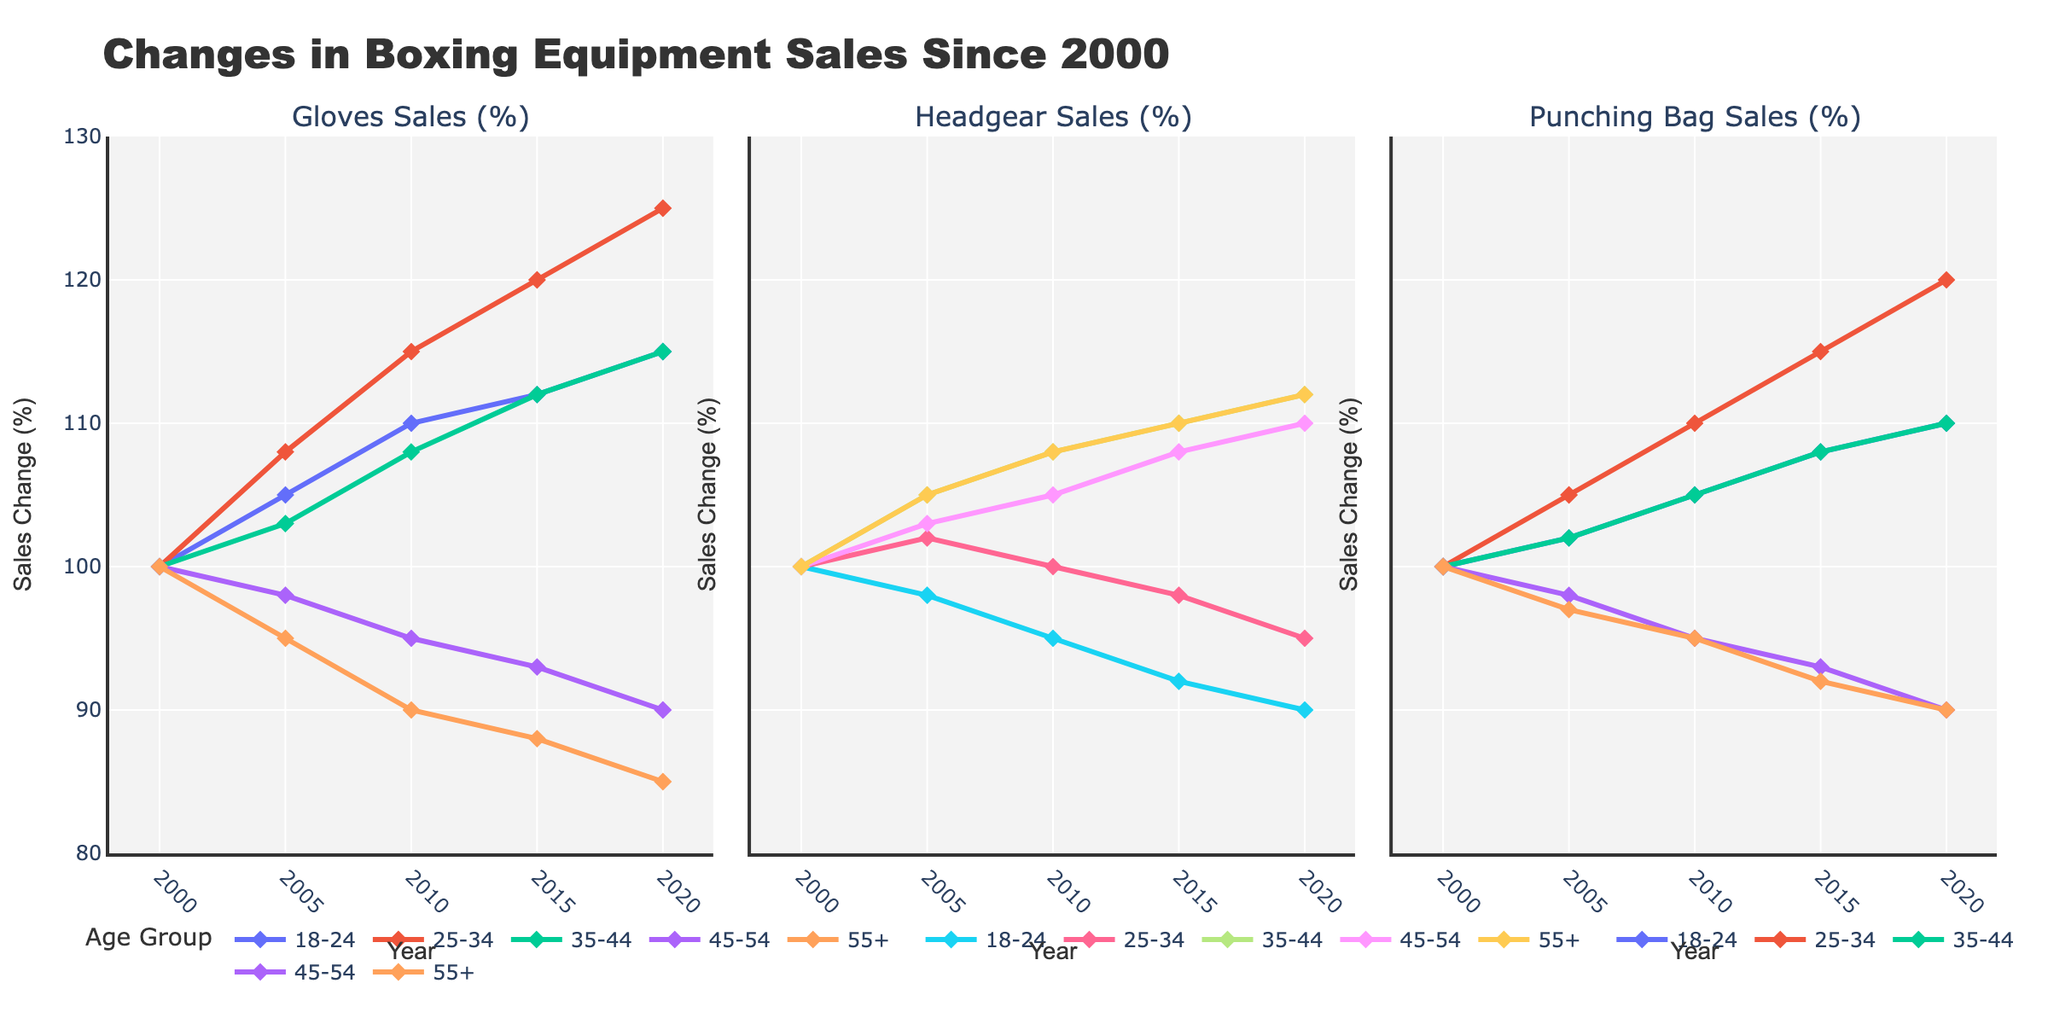Which age group experienced the highest increase in glove sales from 2000 to 2020? Examine the percentage increase for each age group in glove sales from 2000 to 2020. The values are: 18-24 (115-100=15%), 25-34 (125-100=25%), 35-44 (115-100=15%), 45-54 (90-100=-10%), 55+ (85-100=-15%). The group with the highest increase is 25-34.
Answer: 25-34 Which piece of equipment saw a consistent increase in sales across all age groups? Inspect the trend lines for gloves, headgear, and punching bags across age groups from 2000 to 2020. Glove sales increase for all groups, while headgear and punching bag sales decrease for some groups.
Answer: Gloves How did headgear sales for the 45-54 age group change from 2005 to 2020? Look at the headgear sales for the 45-54 age group at 2005 (103%) and 2020 (110%). The change is 110 - 103 = 7%.
Answer: Increased by 7% Which age group had the lowest sales of punching bags in 2020? Compare the punching bag sales percentages for each age group in the year 2020. The values are: 18-24 (110%), 25-34 (120%), 35-44 (110%), 45-54 (90%), 55+ (90%). The lowest values are for 45-54 and 55+, both at 90%.
Answer: 45-54 and 55+ What was the overall trend in glove sales for the 18-24 age group from 2000 to 2020? Observe the trend line for the 18-24 age group in glove sales across the years 2000 to 2020. Glove sales for this age group steadily increased from 100% to 115%.
Answer: Steady increase By how much did punching bag sales for the 25-34 age group increase between 2000 and 2020? Subtract the punching bag sales percentage for the 25-34 age group in 2000 (100%) from the percentage in 2020 (120%). The calculation is 120 - 100 = 20%.
Answer: 20% Which age group had a declining trend in headgear sales from 2000 to 2020? Evaluate each age group's headgear sales over the years. The groups 18-24, 25-34, 45-54, and 55+ show a declining trend.
Answer: 18-24, 25-34, 45-54, and 55+ How did the sales of gloves and headgear for the 35-44 age group compare in 2020? Observe the sales percentages for gloves and headgear in the 35-44 age group in 2020. Glove sales are at 115%, while headgear sales are at 112%.
Answer: Gloves higher Which age group experienced the least change in glove sales from 2000 to 2020? Calculate the absolute change in glove sales for each age group: 18-24 (15), 25-34 (25), 35-44 (15), 45-54 (-10), 55+ (-15). The smallest change is in the 45-54 age group (-10).
Answer: 45-54 What was the percentage increase in glove sales for the 25-34 age group between 2005 and 2015? Find the glove sales values for 25-34 in 2005 (108%) and 2015 (120%). The percentage increase is (120 - 108) / 108 * 100 = 11.1%.
Answer: 11.1% 